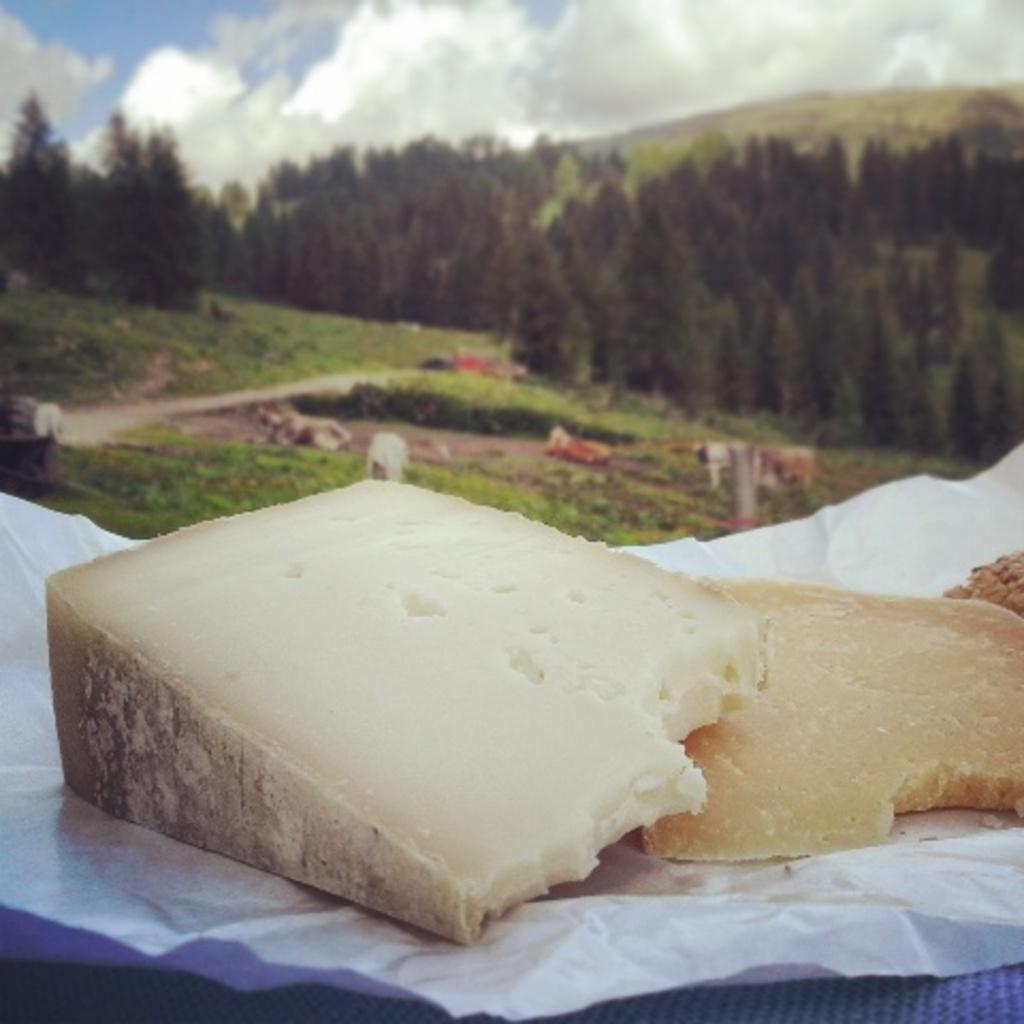In one or two sentences, can you explain what this image depicts? This image is taken outdoors. At the top of the image there is the sky with clouds. In the background there is a hill. There are many trees and plants with leaves, stems and branches. There is a ground with grass on it. There are few cattle. At the bottom of the image there is a table with a food item on it. 